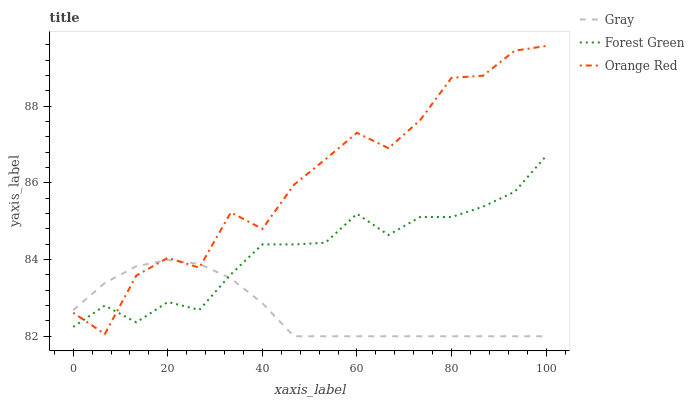Does Gray have the minimum area under the curve?
Answer yes or no. Yes. Does Orange Red have the maximum area under the curve?
Answer yes or no. Yes. Does Forest Green have the minimum area under the curve?
Answer yes or no. No. Does Forest Green have the maximum area under the curve?
Answer yes or no. No. Is Gray the smoothest?
Answer yes or no. Yes. Is Orange Red the roughest?
Answer yes or no. Yes. Is Forest Green the smoothest?
Answer yes or no. No. Is Forest Green the roughest?
Answer yes or no. No. Does Gray have the lowest value?
Answer yes or no. Yes. Does Orange Red have the lowest value?
Answer yes or no. No. Does Orange Red have the highest value?
Answer yes or no. Yes. Does Forest Green have the highest value?
Answer yes or no. No. Does Gray intersect Orange Red?
Answer yes or no. Yes. Is Gray less than Orange Red?
Answer yes or no. No. Is Gray greater than Orange Red?
Answer yes or no. No. 